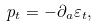<formula> <loc_0><loc_0><loc_500><loc_500>p _ { t } = - \partial _ { a } \varepsilon _ { t } ,</formula> 